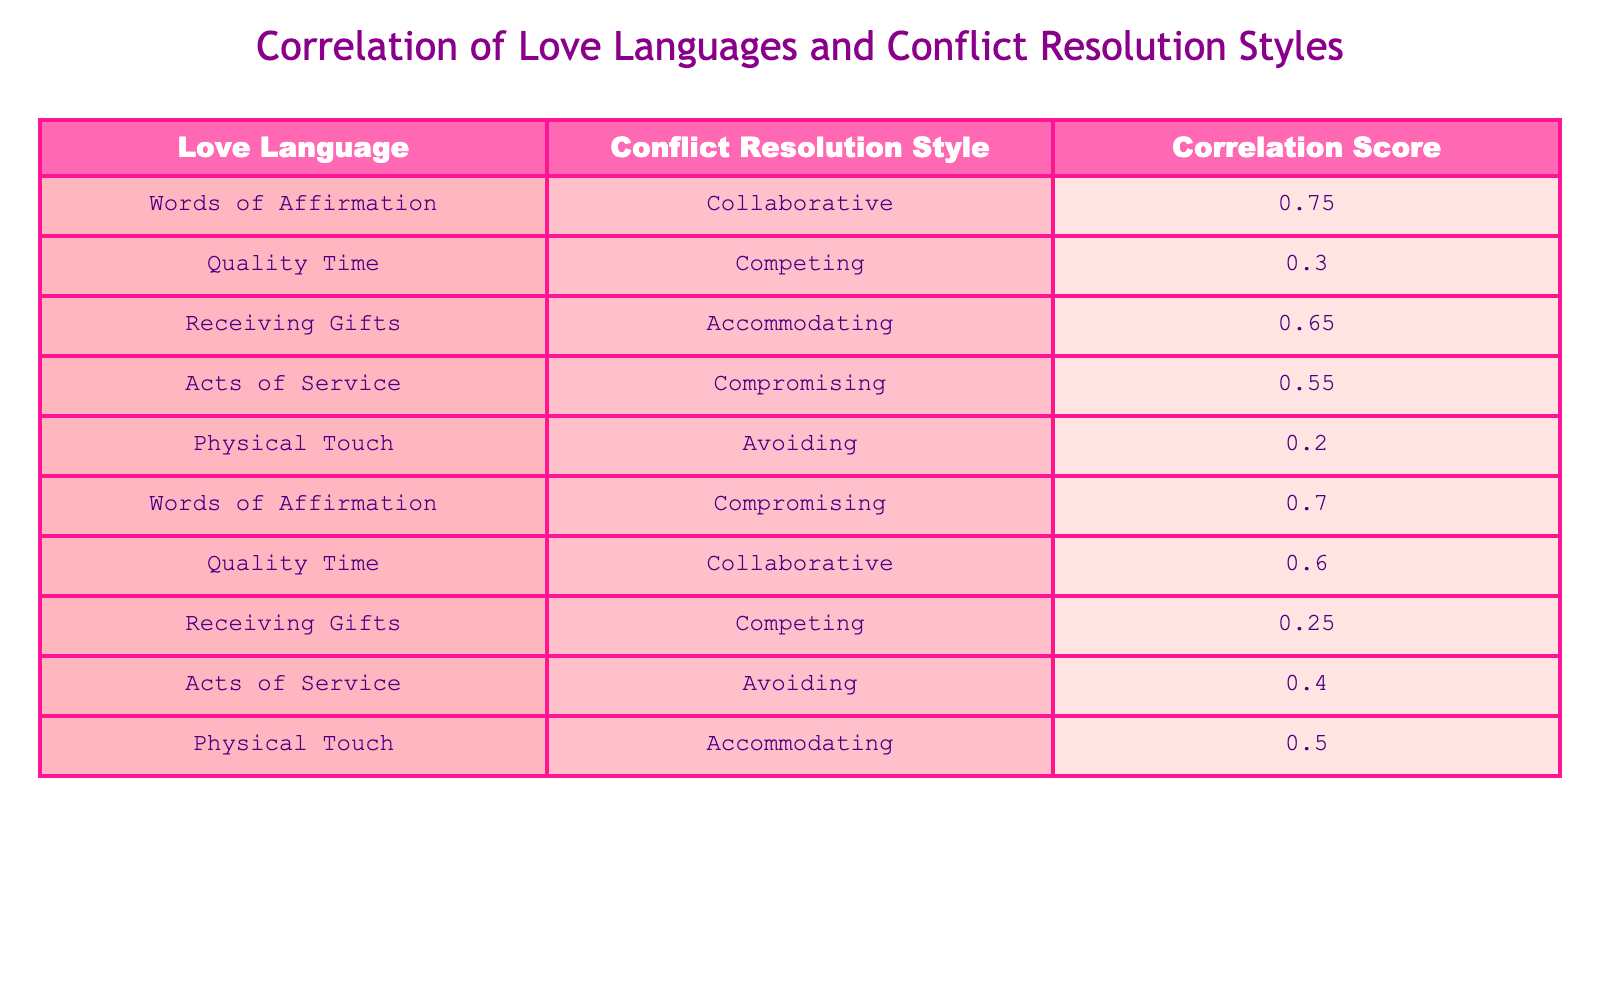What is the correlation score for Words of Affirmation and Collaborative? The table explicitly shows that the correlation score for Words of Affirmation and the Collaborative style is 0.75.
Answer: 0.75 Which Love Language has the lowest correlation with a Conflict Resolution Style? By examining the table, Physical Touch has the lowest correlation with Avoiding, showing a score of 0.20.
Answer: Physical Touch What is the correlation score for Quality Time with the Competing style? The table lists the correlation score for Quality Time and Competing as 0.30.
Answer: 0.30 What is the average correlation score across all pairs in the table? First, find the total of all correlation scores: (0.75 + 0.30 + 0.65 + 0.55 + 0.20 + 0.70 + 0.60 + 0.25 + 0.40 + 0.50) = 5.70. Then, there are 10 scores, so the average is 5.70 / 10 = 0.57.
Answer: 0.57 Is there a stronger correlation between Words of Affirmation and Compromising compared to Receiving Gifts and Competing? The table shows that the correlation between Words of Affirmation and Compromising is 0.70 while Receiving Gifts and Competing has a correlation of 0.25. Since 0.70 is greater than 0.25, the statement is true.
Answer: Yes What two Conflict Resolution Styles correlate with the Love Language Acts of Service, and what are their scores? The table reveals that Acts of Service has a correlation of 0.55 with Compromising and 0.40 with Avoiding.
Answer: Compromising (0.55), Avoiding (0.40) Calculate the difference in correlation scores between Physical Touch and Accommodating versus Words of Affirmation and Collaborative. The correlation for Physical Touch and Accommodating is 0.50 and for Words of Affirmation and Collaborative is 0.75. The difference is 0.75 - 0.50 = 0.25.
Answer: 0.25 Are there more Love Languages correlated positively with Collaborative than with Competing? From the table, Words of Affirmation and Quality Time are correlated positively with Collaborative (2 instances), while only Quality Time is positively correlated with Competing (1 instance). So the statement is true.
Answer: Yes 